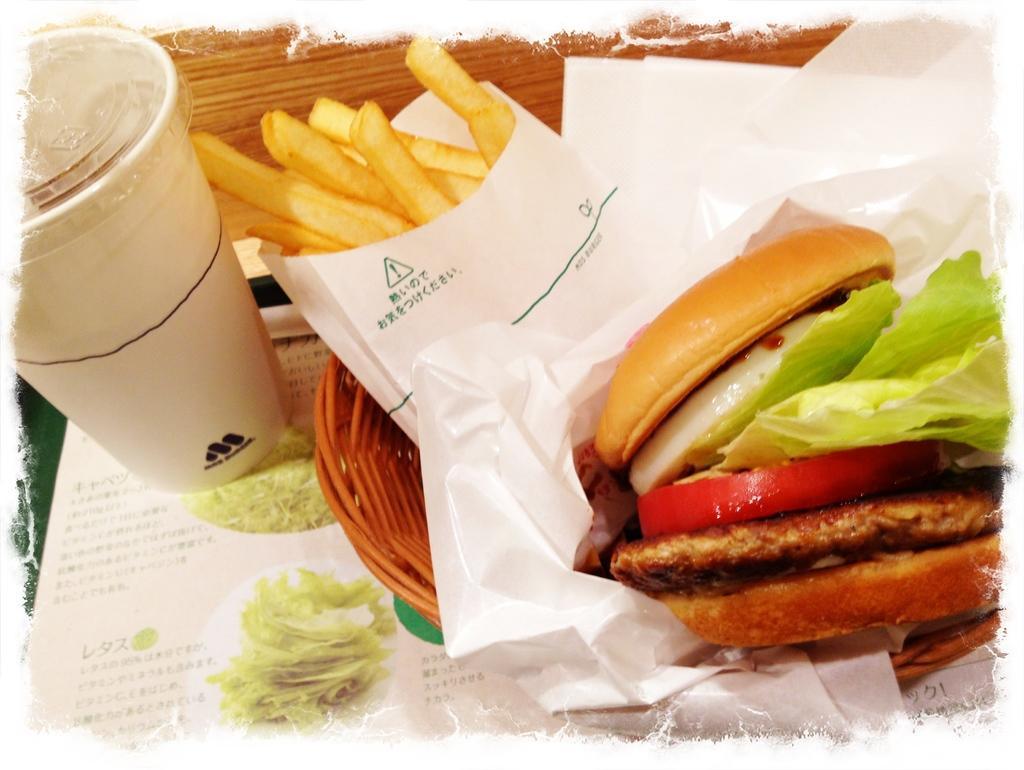How would you summarize this image in a sentence or two? In this image we can see a burger, there are french fries, where is the glass on the table, there is a food item in the basket. 